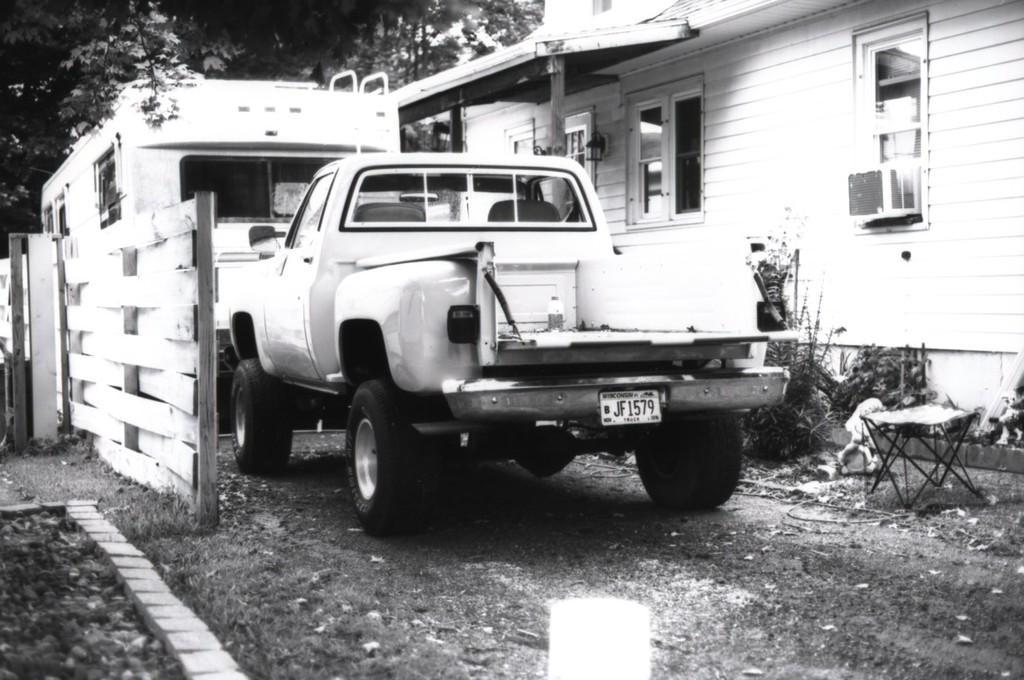Could you give a brief overview of what you see in this image? This is a black and white image. In this image, in the middle, we can see a vehicle which is placed on the road. On the right side, we can see a table, few plants and a building. On the building, we can see a glass window, air conditioner, pillars and a roof. On the left side, we can see pillars, wall. In the background, we can also see a vehicle. At the top, we can see some trees, at the bottom, we can see a land. 